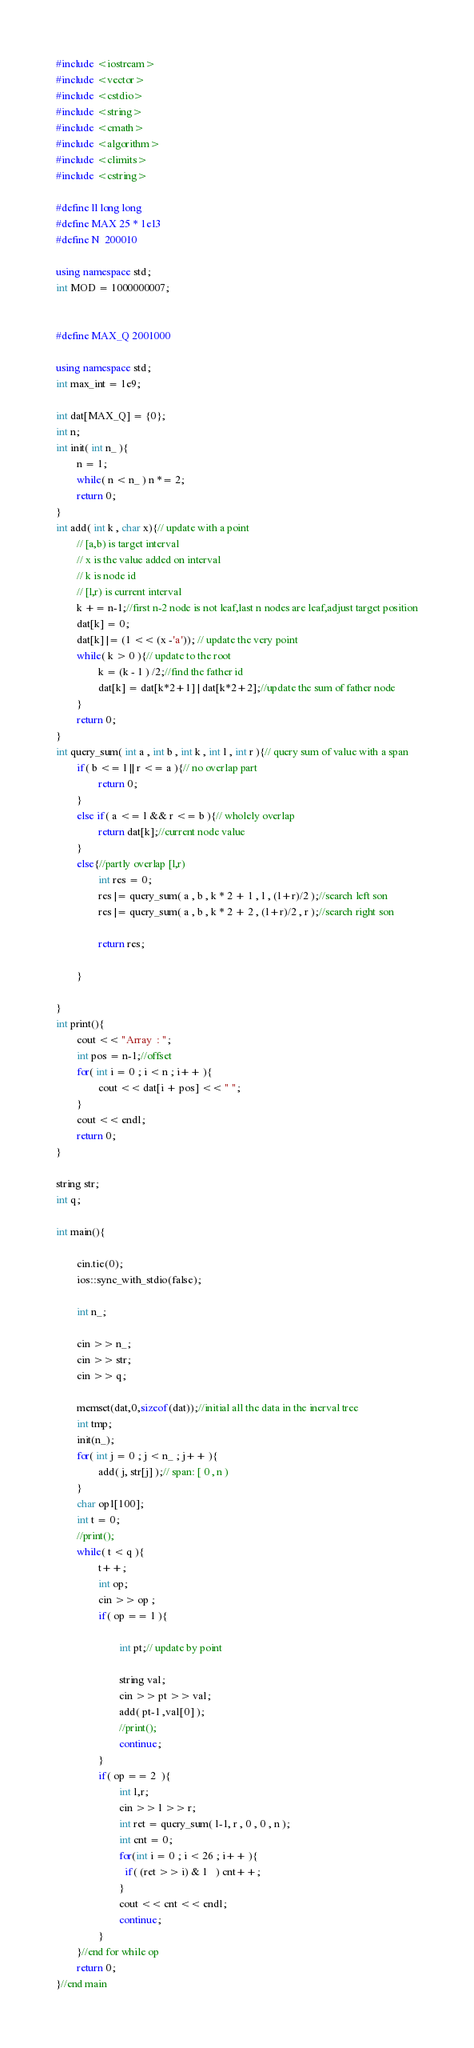Convert code to text. <code><loc_0><loc_0><loc_500><loc_500><_C++_>#include <iostream>
#include <vector>
#include <cstdio>
#include <string>
#include <cmath>
#include <algorithm>
#include <climits>
#include <cstring>

#define ll long long
#define MAX 25 * 1e13
#define N  200010

using namespace std;
int MOD = 1000000007;


#define MAX_Q 2001000

using namespace std;
int max_int = 1e9;

int dat[MAX_Q] = {0};
int n;
int init( int n_ ){
        n = 1;
        while( n < n_ ) n *= 2;
        return 0;
}
int add( int k , char x){// update with a point
        // [a,b) is target interval
        // x is the value added on interval
        // k is node id
        // [l,r) is current interval
        k += n-1;//first n-2 node is not leaf,last n nodes are leaf,adjust target position
        dat[k] = 0;
        dat[k] |= (1 << (x -'a')); // update the very point
        while( k > 0 ){// update to the root
                k = (k - 1 ) /2;//find the father id
                dat[k] = dat[k*2+1] | dat[k*2+2];//update the sum of father node
        }
        return 0;
}
int query_sum( int a , int b , int k , int l , int r ){// query sum of value with a span
        if( b <= l || r <= a ){// no overlap part
                return 0;
        }
        else if( a <= l && r <= b ){// wholely overlap
                return dat[k];//current node value
        }
        else{//partly overlap [l,r)
                int res = 0;
                res |= query_sum( a , b , k * 2 + 1 , l , (l+r)/2 );//search left son 
                res |= query_sum( a , b , k * 2 + 2 , (l+r)/2 , r );//search right son

                return res;

        }

}
int print(){
        cout << "Array  : ";
        int pos = n-1;//offset
        for( int i = 0 ; i < n ; i++ ){
                cout << dat[i + pos] << " ";
        }
        cout << endl;
        return 0;
}

string str;
int q;

int main(){

        cin.tie(0);
        ios::sync_with_stdio(false);

        int n_;

        cin >> n_;
        cin >> str;
        cin >> q;

        memset(dat,0,sizeof(dat));//initial all the data in the inerval tree
        int tmp;
        init(n_);
        for( int j = 0 ; j < n_ ; j++ ){
                add( j, str[j] );// span: [ 0 , n )
        }
        char op1[100];
        int t = 0;
        //print();
        while( t < q ){
                t++;
                int op;
                cin >> op ;
                if( op == 1 ){
                        
                        int pt;// update by point
                        
                        string val;
                        cin >> pt >> val;
                        add( pt-1 ,val[0] );
                        //print();
                        continue;
                }
                if( op == 2  ){
                        int l,r;
                        cin >> l >> r;
                        int ret = query_sum( l-1, r , 0 , 0 , n );
                        int cnt = 0;
                        for(int i = 0 ; i < 26 ; i++ ){
                          if( (ret >> i) & 1   ) cnt++;
                        }
                        cout << cnt << endl;
                        continue;
                }
        }//end for while op
        return 0;
}//end main

</code> 